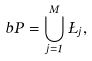Convert formula to latex. <formula><loc_0><loc_0><loc_500><loc_500>b P = \bigcup _ { j = 1 } ^ { M } \Sigma _ { j } ,</formula> 